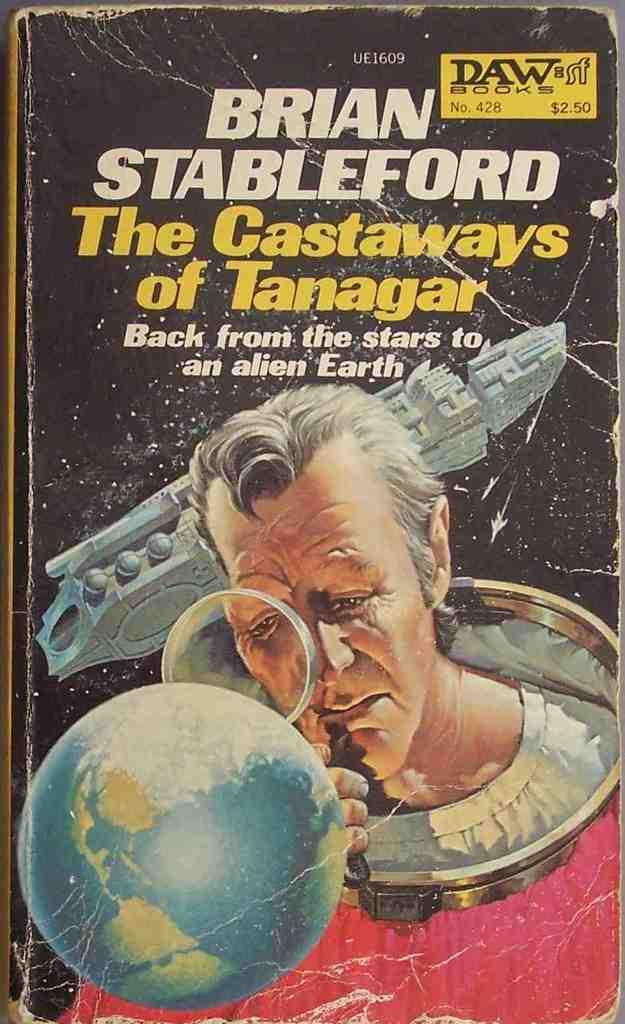<image>
Provide a brief description of the given image. a Brian Stableford book that has a man on it 